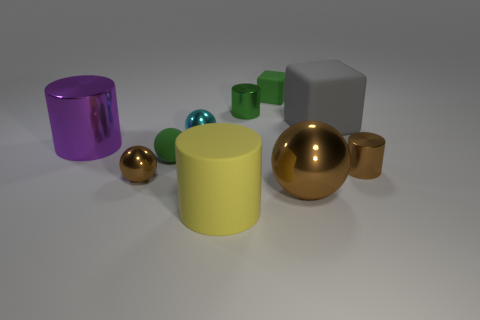What number of other things are made of the same material as the brown cylinder?
Keep it short and to the point. 5. What number of big objects are the same color as the big shiny sphere?
Ensure brevity in your answer.  0. How big is the shiny cylinder that is left of the small green rubber thing in front of the green object that is behind the tiny green metallic thing?
Offer a terse response. Large. What number of shiny things are purple cylinders or big green objects?
Provide a succinct answer. 1. Is the shape of the large gray thing the same as the tiny green rubber thing that is in front of the gray rubber block?
Your answer should be compact. No. Are there more cylinders to the left of the gray thing than brown metallic objects left of the big purple metal cylinder?
Provide a short and direct response. Yes. Are there any other things that have the same color as the rubber cylinder?
Keep it short and to the point. No. There is a tiny shiny thing that is on the right side of the brown sphere that is on the right side of the matte ball; are there any small shiny cylinders that are behind it?
Your answer should be compact. Yes. Does the small brown object that is right of the yellow rubber thing have the same shape as the green shiny thing?
Provide a succinct answer. Yes. Is the number of brown metal spheres right of the large yellow cylinder less than the number of tiny balls that are on the left side of the cyan metallic sphere?
Offer a terse response. Yes. 